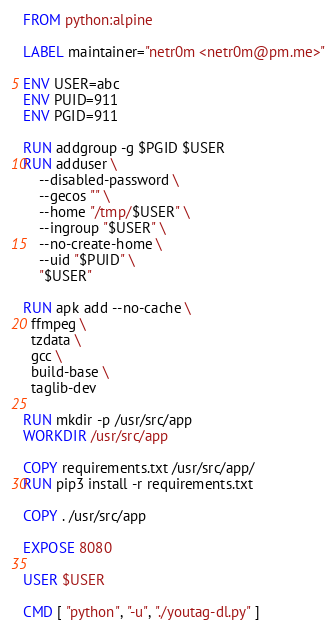<code> <loc_0><loc_0><loc_500><loc_500><_Dockerfile_>FROM python:alpine

LABEL maintainer="netr0m <netr0m@pm.me>"

ENV USER=abc
ENV PUID=911
ENV PGID=911

RUN addgroup -g $PGID $USER
RUN adduser \
    --disabled-password \
    --gecos "" \
    --home "/tmp/$USER" \
    --ingroup "$USER" \
    --no-create-home \
    --uid "$PUID" \
    "$USER"

RUN apk add --no-cache \
  ffmpeg \
  tzdata \
  gcc \
  build-base \
  taglib-dev
      
RUN mkdir -p /usr/src/app
WORKDIR /usr/src/app

COPY requirements.txt /usr/src/app/
RUN pip3 install -r requirements.txt

COPY . /usr/src/app

EXPOSE 8080

USER $USER

CMD [ "python", "-u", "./youtag-dl.py" ]
</code> 